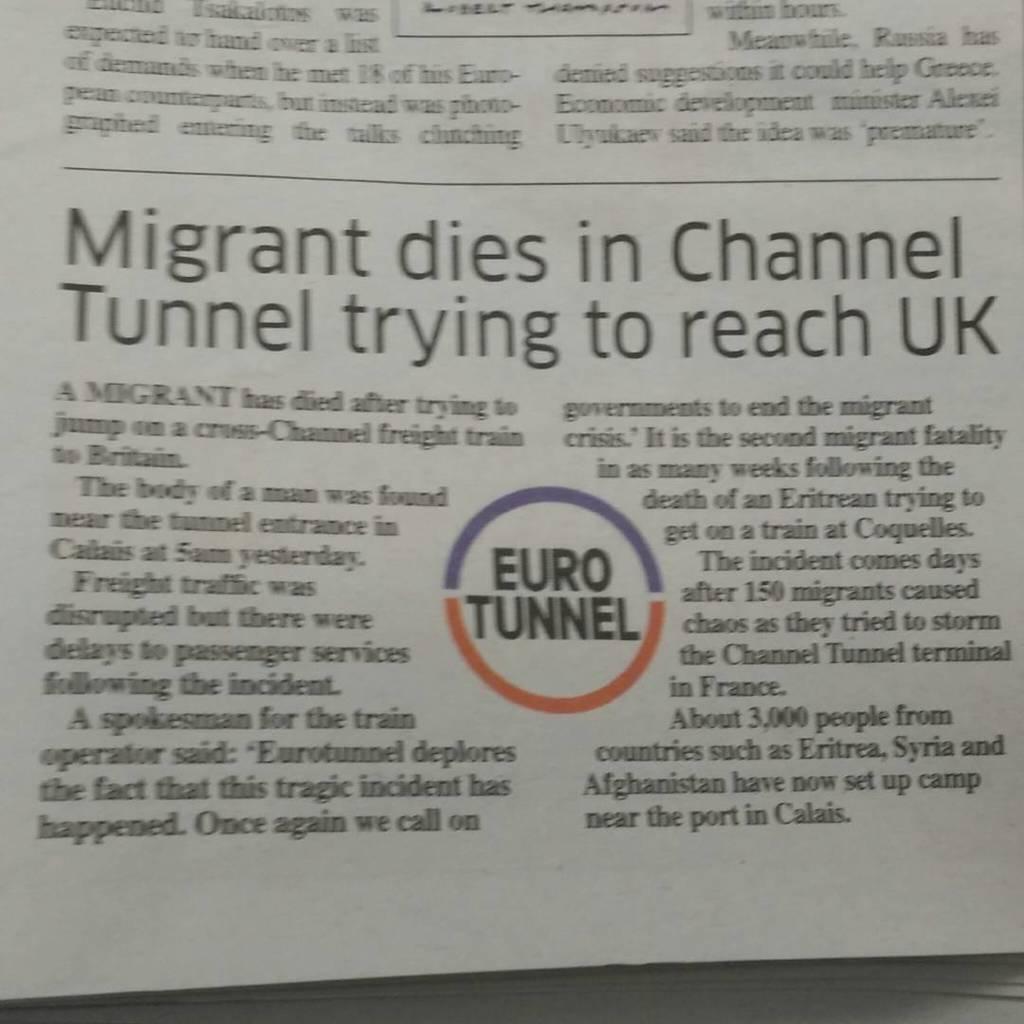What is the name of the article?
Provide a short and direct response. Migrant dies in channel tunnel trying to reach uk. 